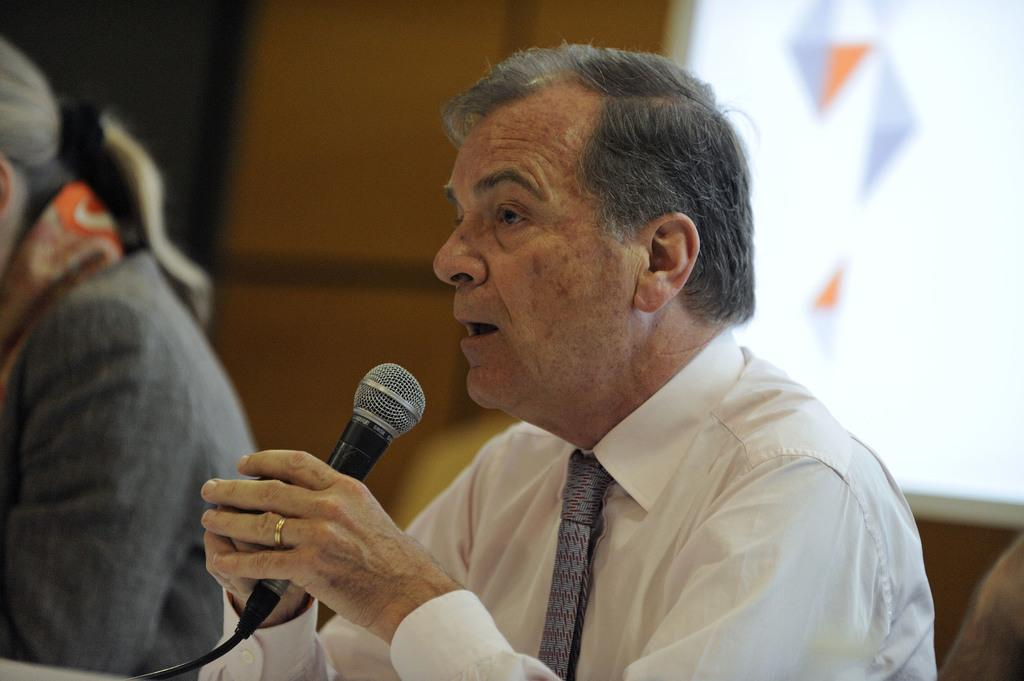How many people are present in the image? There are two persons sitting in the image. What is one person doing with their hands? One person is holding a microphone. What is the person with the microphone doing? The person with the microphone is talking. What can be seen in the background of the image? There is a wall and a screen in the background of the image. What type of smell can be detected from the image? There is no information about smells in the image, as it is a visual medium. 